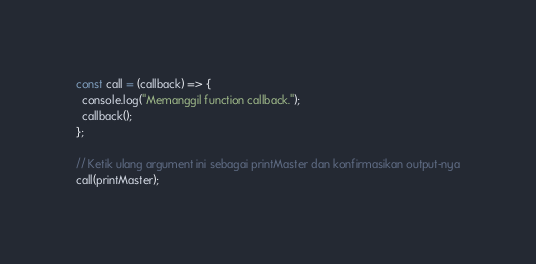Convert code to text. <code><loc_0><loc_0><loc_500><loc_500><_JavaScript_>const call = (callback) => {
  console.log("Memanggil function callback.");
  callback();
};

// Ketik ulang argument ini sebagai printMaster dan konfirmasikan output-nya
call(printMaster);
</code> 